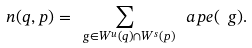<formula> <loc_0><loc_0><loc_500><loc_500>n ( q , p ) = \sum _ { \ g \in W ^ { u } ( q ) \cap W ^ { s } ( p ) } \ a p e ( \ g ) .</formula> 